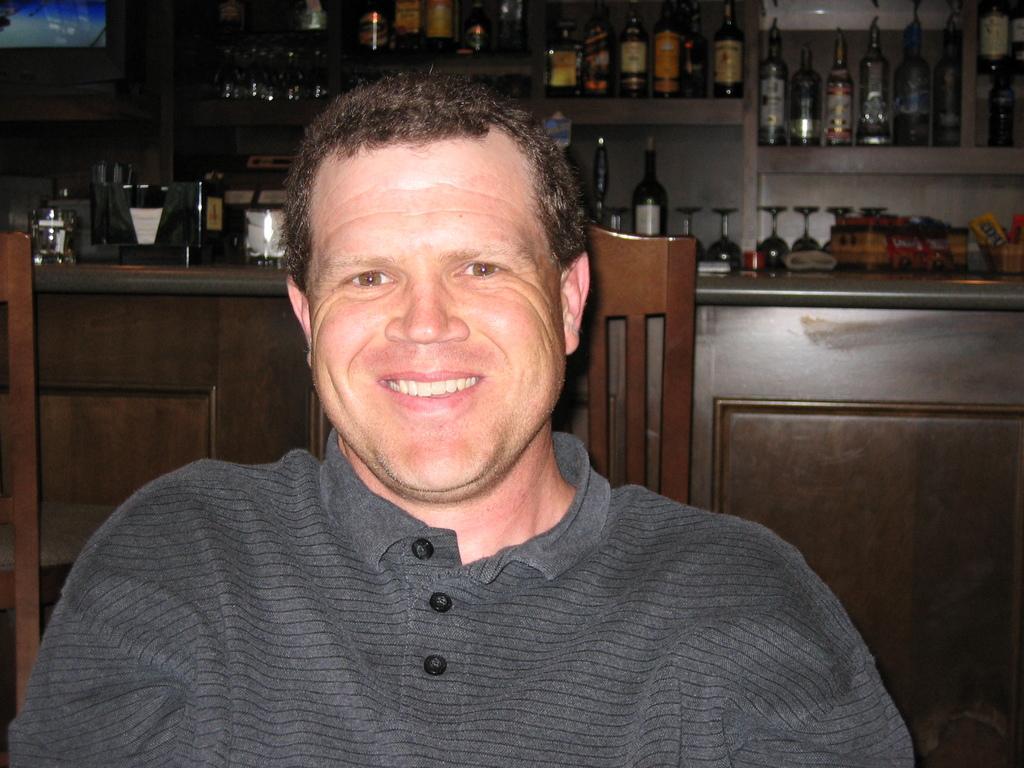In one or two sentences, can you explain what this image depicts? In this picture I can see a man in front who is wearing a t-shirt and is sitting on a chair. In the background I can see the bottles and glasses on the racks. 